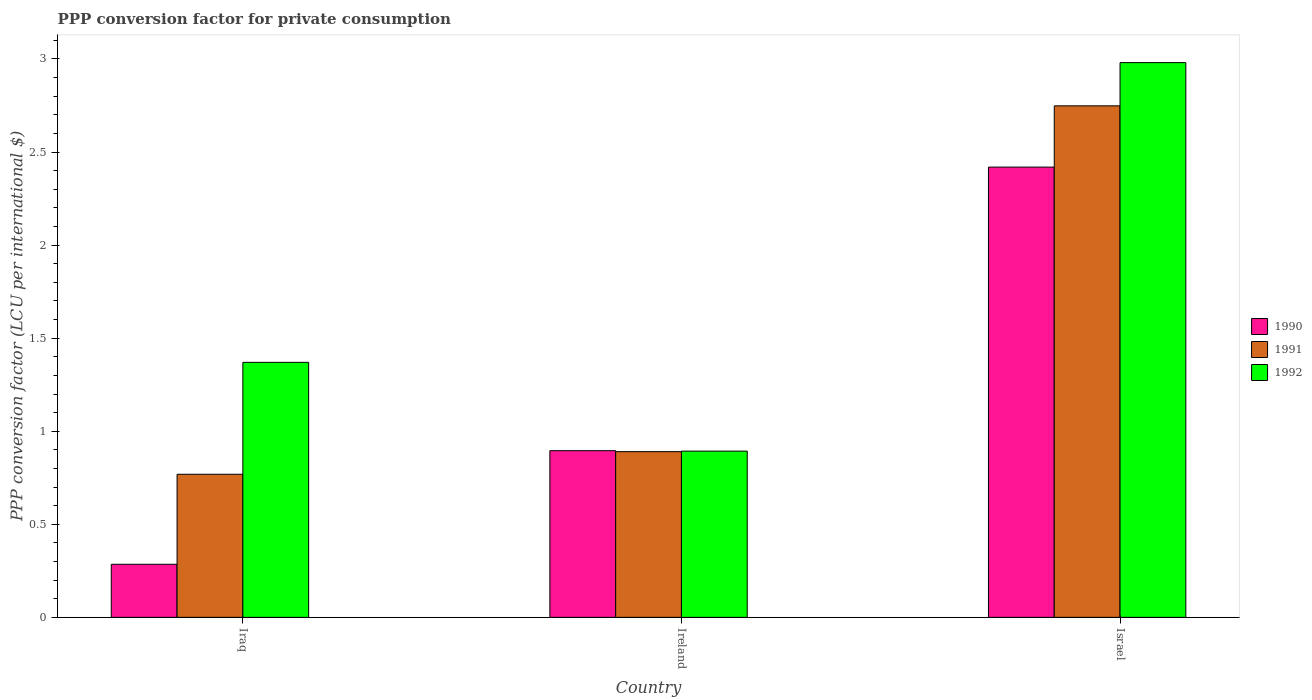How many different coloured bars are there?
Ensure brevity in your answer.  3. Are the number of bars per tick equal to the number of legend labels?
Provide a short and direct response. Yes. How many bars are there on the 3rd tick from the right?
Your answer should be very brief. 3. What is the label of the 1st group of bars from the left?
Your answer should be very brief. Iraq. In how many cases, is the number of bars for a given country not equal to the number of legend labels?
Give a very brief answer. 0. What is the PPP conversion factor for private consumption in 1990 in Israel?
Offer a terse response. 2.42. Across all countries, what is the maximum PPP conversion factor for private consumption in 1991?
Keep it short and to the point. 2.75. Across all countries, what is the minimum PPP conversion factor for private consumption in 1992?
Ensure brevity in your answer.  0.89. In which country was the PPP conversion factor for private consumption in 1992 maximum?
Provide a short and direct response. Israel. In which country was the PPP conversion factor for private consumption in 1991 minimum?
Provide a succinct answer. Iraq. What is the total PPP conversion factor for private consumption in 1992 in the graph?
Make the answer very short. 5.24. What is the difference between the PPP conversion factor for private consumption in 1992 in Ireland and that in Israel?
Your answer should be very brief. -2.09. What is the difference between the PPP conversion factor for private consumption in 1990 in Ireland and the PPP conversion factor for private consumption in 1992 in Israel?
Your response must be concise. -2.08. What is the average PPP conversion factor for private consumption in 1991 per country?
Provide a succinct answer. 1.47. What is the difference between the PPP conversion factor for private consumption of/in 1990 and PPP conversion factor for private consumption of/in 1992 in Iraq?
Provide a succinct answer. -1.08. What is the ratio of the PPP conversion factor for private consumption in 1992 in Ireland to that in Israel?
Your answer should be compact. 0.3. What is the difference between the highest and the second highest PPP conversion factor for private consumption in 1991?
Keep it short and to the point. 0.12. What is the difference between the highest and the lowest PPP conversion factor for private consumption in 1991?
Offer a very short reply. 1.98. Is the sum of the PPP conversion factor for private consumption in 1991 in Ireland and Israel greater than the maximum PPP conversion factor for private consumption in 1992 across all countries?
Provide a succinct answer. Yes. Is it the case that in every country, the sum of the PPP conversion factor for private consumption in 1992 and PPP conversion factor for private consumption in 1991 is greater than the PPP conversion factor for private consumption in 1990?
Keep it short and to the point. Yes. How many bars are there?
Your answer should be compact. 9. Are the values on the major ticks of Y-axis written in scientific E-notation?
Provide a succinct answer. No. Does the graph contain grids?
Provide a succinct answer. No. How are the legend labels stacked?
Ensure brevity in your answer.  Vertical. What is the title of the graph?
Provide a succinct answer. PPP conversion factor for private consumption. Does "1974" appear as one of the legend labels in the graph?
Offer a very short reply. No. What is the label or title of the X-axis?
Provide a succinct answer. Country. What is the label or title of the Y-axis?
Your response must be concise. PPP conversion factor (LCU per international $). What is the PPP conversion factor (LCU per international $) of 1990 in Iraq?
Give a very brief answer. 0.29. What is the PPP conversion factor (LCU per international $) in 1991 in Iraq?
Your response must be concise. 0.77. What is the PPP conversion factor (LCU per international $) in 1992 in Iraq?
Your response must be concise. 1.37. What is the PPP conversion factor (LCU per international $) in 1990 in Ireland?
Ensure brevity in your answer.  0.9. What is the PPP conversion factor (LCU per international $) in 1991 in Ireland?
Provide a short and direct response. 0.89. What is the PPP conversion factor (LCU per international $) of 1992 in Ireland?
Provide a short and direct response. 0.89. What is the PPP conversion factor (LCU per international $) in 1990 in Israel?
Your answer should be very brief. 2.42. What is the PPP conversion factor (LCU per international $) in 1991 in Israel?
Keep it short and to the point. 2.75. What is the PPP conversion factor (LCU per international $) of 1992 in Israel?
Your response must be concise. 2.98. Across all countries, what is the maximum PPP conversion factor (LCU per international $) in 1990?
Keep it short and to the point. 2.42. Across all countries, what is the maximum PPP conversion factor (LCU per international $) in 1991?
Your answer should be very brief. 2.75. Across all countries, what is the maximum PPP conversion factor (LCU per international $) in 1992?
Provide a short and direct response. 2.98. Across all countries, what is the minimum PPP conversion factor (LCU per international $) of 1990?
Ensure brevity in your answer.  0.29. Across all countries, what is the minimum PPP conversion factor (LCU per international $) of 1991?
Offer a very short reply. 0.77. Across all countries, what is the minimum PPP conversion factor (LCU per international $) in 1992?
Keep it short and to the point. 0.89. What is the total PPP conversion factor (LCU per international $) of 1990 in the graph?
Give a very brief answer. 3.6. What is the total PPP conversion factor (LCU per international $) in 1991 in the graph?
Make the answer very short. 4.41. What is the total PPP conversion factor (LCU per international $) in 1992 in the graph?
Your response must be concise. 5.24. What is the difference between the PPP conversion factor (LCU per international $) in 1990 in Iraq and that in Ireland?
Make the answer very short. -0.61. What is the difference between the PPP conversion factor (LCU per international $) in 1991 in Iraq and that in Ireland?
Your answer should be compact. -0.12. What is the difference between the PPP conversion factor (LCU per international $) of 1992 in Iraq and that in Ireland?
Your response must be concise. 0.48. What is the difference between the PPP conversion factor (LCU per international $) in 1990 in Iraq and that in Israel?
Provide a short and direct response. -2.13. What is the difference between the PPP conversion factor (LCU per international $) of 1991 in Iraq and that in Israel?
Offer a terse response. -1.98. What is the difference between the PPP conversion factor (LCU per international $) of 1992 in Iraq and that in Israel?
Offer a very short reply. -1.61. What is the difference between the PPP conversion factor (LCU per international $) in 1990 in Ireland and that in Israel?
Keep it short and to the point. -1.52. What is the difference between the PPP conversion factor (LCU per international $) in 1991 in Ireland and that in Israel?
Your answer should be compact. -1.86. What is the difference between the PPP conversion factor (LCU per international $) of 1992 in Ireland and that in Israel?
Give a very brief answer. -2.09. What is the difference between the PPP conversion factor (LCU per international $) in 1990 in Iraq and the PPP conversion factor (LCU per international $) in 1991 in Ireland?
Provide a succinct answer. -0.61. What is the difference between the PPP conversion factor (LCU per international $) in 1990 in Iraq and the PPP conversion factor (LCU per international $) in 1992 in Ireland?
Provide a succinct answer. -0.61. What is the difference between the PPP conversion factor (LCU per international $) of 1991 in Iraq and the PPP conversion factor (LCU per international $) of 1992 in Ireland?
Give a very brief answer. -0.12. What is the difference between the PPP conversion factor (LCU per international $) of 1990 in Iraq and the PPP conversion factor (LCU per international $) of 1991 in Israel?
Provide a short and direct response. -2.46. What is the difference between the PPP conversion factor (LCU per international $) in 1990 in Iraq and the PPP conversion factor (LCU per international $) in 1992 in Israel?
Give a very brief answer. -2.7. What is the difference between the PPP conversion factor (LCU per international $) of 1991 in Iraq and the PPP conversion factor (LCU per international $) of 1992 in Israel?
Your answer should be compact. -2.21. What is the difference between the PPP conversion factor (LCU per international $) of 1990 in Ireland and the PPP conversion factor (LCU per international $) of 1991 in Israel?
Provide a succinct answer. -1.85. What is the difference between the PPP conversion factor (LCU per international $) in 1990 in Ireland and the PPP conversion factor (LCU per international $) in 1992 in Israel?
Provide a succinct answer. -2.08. What is the difference between the PPP conversion factor (LCU per international $) of 1991 in Ireland and the PPP conversion factor (LCU per international $) of 1992 in Israel?
Provide a short and direct response. -2.09. What is the average PPP conversion factor (LCU per international $) of 1990 per country?
Your answer should be compact. 1.2. What is the average PPP conversion factor (LCU per international $) in 1991 per country?
Give a very brief answer. 1.47. What is the average PPP conversion factor (LCU per international $) of 1992 per country?
Your answer should be very brief. 1.75. What is the difference between the PPP conversion factor (LCU per international $) in 1990 and PPP conversion factor (LCU per international $) in 1991 in Iraq?
Ensure brevity in your answer.  -0.48. What is the difference between the PPP conversion factor (LCU per international $) of 1990 and PPP conversion factor (LCU per international $) of 1992 in Iraq?
Your answer should be compact. -1.08. What is the difference between the PPP conversion factor (LCU per international $) in 1991 and PPP conversion factor (LCU per international $) in 1992 in Iraq?
Give a very brief answer. -0.6. What is the difference between the PPP conversion factor (LCU per international $) of 1990 and PPP conversion factor (LCU per international $) of 1991 in Ireland?
Offer a terse response. 0.01. What is the difference between the PPP conversion factor (LCU per international $) of 1990 and PPP conversion factor (LCU per international $) of 1992 in Ireland?
Provide a short and direct response. 0. What is the difference between the PPP conversion factor (LCU per international $) of 1991 and PPP conversion factor (LCU per international $) of 1992 in Ireland?
Provide a short and direct response. -0. What is the difference between the PPP conversion factor (LCU per international $) of 1990 and PPP conversion factor (LCU per international $) of 1991 in Israel?
Offer a very short reply. -0.33. What is the difference between the PPP conversion factor (LCU per international $) in 1990 and PPP conversion factor (LCU per international $) in 1992 in Israel?
Ensure brevity in your answer.  -0.56. What is the difference between the PPP conversion factor (LCU per international $) of 1991 and PPP conversion factor (LCU per international $) of 1992 in Israel?
Offer a terse response. -0.23. What is the ratio of the PPP conversion factor (LCU per international $) of 1990 in Iraq to that in Ireland?
Make the answer very short. 0.32. What is the ratio of the PPP conversion factor (LCU per international $) in 1991 in Iraq to that in Ireland?
Your answer should be very brief. 0.86. What is the ratio of the PPP conversion factor (LCU per international $) in 1992 in Iraq to that in Ireland?
Give a very brief answer. 1.53. What is the ratio of the PPP conversion factor (LCU per international $) of 1990 in Iraq to that in Israel?
Offer a terse response. 0.12. What is the ratio of the PPP conversion factor (LCU per international $) in 1991 in Iraq to that in Israel?
Ensure brevity in your answer.  0.28. What is the ratio of the PPP conversion factor (LCU per international $) of 1992 in Iraq to that in Israel?
Ensure brevity in your answer.  0.46. What is the ratio of the PPP conversion factor (LCU per international $) of 1990 in Ireland to that in Israel?
Give a very brief answer. 0.37. What is the ratio of the PPP conversion factor (LCU per international $) of 1991 in Ireland to that in Israel?
Your answer should be compact. 0.32. What is the ratio of the PPP conversion factor (LCU per international $) of 1992 in Ireland to that in Israel?
Your answer should be compact. 0.3. What is the difference between the highest and the second highest PPP conversion factor (LCU per international $) in 1990?
Provide a succinct answer. 1.52. What is the difference between the highest and the second highest PPP conversion factor (LCU per international $) in 1991?
Provide a short and direct response. 1.86. What is the difference between the highest and the second highest PPP conversion factor (LCU per international $) in 1992?
Offer a terse response. 1.61. What is the difference between the highest and the lowest PPP conversion factor (LCU per international $) of 1990?
Provide a succinct answer. 2.13. What is the difference between the highest and the lowest PPP conversion factor (LCU per international $) in 1991?
Your answer should be compact. 1.98. What is the difference between the highest and the lowest PPP conversion factor (LCU per international $) in 1992?
Keep it short and to the point. 2.09. 